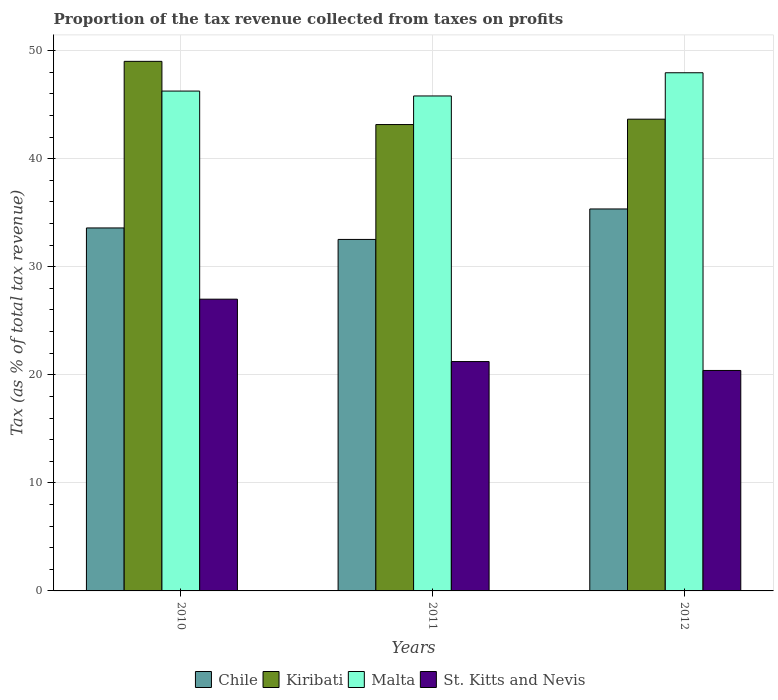How many different coloured bars are there?
Offer a very short reply. 4. What is the label of the 2nd group of bars from the left?
Your answer should be very brief. 2011. In how many cases, is the number of bars for a given year not equal to the number of legend labels?
Offer a very short reply. 0. What is the proportion of the tax revenue collected in Kiribati in 2011?
Your answer should be very brief. 43.16. Across all years, what is the maximum proportion of the tax revenue collected in St. Kitts and Nevis?
Your answer should be compact. 27. Across all years, what is the minimum proportion of the tax revenue collected in St. Kitts and Nevis?
Keep it short and to the point. 20.4. In which year was the proportion of the tax revenue collected in Chile maximum?
Offer a very short reply. 2012. What is the total proportion of the tax revenue collected in Chile in the graph?
Provide a succinct answer. 101.46. What is the difference between the proportion of the tax revenue collected in St. Kitts and Nevis in 2010 and that in 2011?
Ensure brevity in your answer.  5.77. What is the difference between the proportion of the tax revenue collected in Kiribati in 2011 and the proportion of the tax revenue collected in Chile in 2012?
Your response must be concise. 7.81. What is the average proportion of the tax revenue collected in St. Kitts and Nevis per year?
Offer a very short reply. 22.87. In the year 2010, what is the difference between the proportion of the tax revenue collected in Chile and proportion of the tax revenue collected in Malta?
Your response must be concise. -12.67. In how many years, is the proportion of the tax revenue collected in Chile greater than 28 %?
Provide a short and direct response. 3. What is the ratio of the proportion of the tax revenue collected in St. Kitts and Nevis in 2011 to that in 2012?
Provide a succinct answer. 1.04. Is the proportion of the tax revenue collected in Malta in 2010 less than that in 2011?
Ensure brevity in your answer.  No. What is the difference between the highest and the second highest proportion of the tax revenue collected in Chile?
Your answer should be very brief. 1.76. What is the difference between the highest and the lowest proportion of the tax revenue collected in Kiribati?
Your response must be concise. 5.85. In how many years, is the proportion of the tax revenue collected in Malta greater than the average proportion of the tax revenue collected in Malta taken over all years?
Your answer should be very brief. 1. Is the sum of the proportion of the tax revenue collected in Malta in 2010 and 2011 greater than the maximum proportion of the tax revenue collected in Kiribati across all years?
Offer a very short reply. Yes. What does the 4th bar from the left in 2011 represents?
Give a very brief answer. St. Kitts and Nevis. What does the 4th bar from the right in 2011 represents?
Your answer should be compact. Chile. How many years are there in the graph?
Give a very brief answer. 3. Does the graph contain any zero values?
Keep it short and to the point. No. What is the title of the graph?
Provide a short and direct response. Proportion of the tax revenue collected from taxes on profits. Does "Europe(developing only)" appear as one of the legend labels in the graph?
Your answer should be very brief. No. What is the label or title of the Y-axis?
Offer a terse response. Tax (as % of total tax revenue). What is the Tax (as % of total tax revenue) in Chile in 2010?
Provide a succinct answer. 33.59. What is the Tax (as % of total tax revenue) of Kiribati in 2010?
Offer a terse response. 49. What is the Tax (as % of total tax revenue) in Malta in 2010?
Provide a short and direct response. 46.25. What is the Tax (as % of total tax revenue) of St. Kitts and Nevis in 2010?
Give a very brief answer. 27. What is the Tax (as % of total tax revenue) in Chile in 2011?
Your response must be concise. 32.53. What is the Tax (as % of total tax revenue) in Kiribati in 2011?
Provide a short and direct response. 43.16. What is the Tax (as % of total tax revenue) in Malta in 2011?
Provide a succinct answer. 45.8. What is the Tax (as % of total tax revenue) in St. Kitts and Nevis in 2011?
Offer a very short reply. 21.23. What is the Tax (as % of total tax revenue) of Chile in 2012?
Offer a very short reply. 35.35. What is the Tax (as % of total tax revenue) in Kiribati in 2012?
Your answer should be compact. 43.65. What is the Tax (as % of total tax revenue) in Malta in 2012?
Keep it short and to the point. 47.95. What is the Tax (as % of total tax revenue) in St. Kitts and Nevis in 2012?
Your response must be concise. 20.4. Across all years, what is the maximum Tax (as % of total tax revenue) of Chile?
Your answer should be compact. 35.35. Across all years, what is the maximum Tax (as % of total tax revenue) of Kiribati?
Offer a very short reply. 49. Across all years, what is the maximum Tax (as % of total tax revenue) of Malta?
Provide a succinct answer. 47.95. Across all years, what is the maximum Tax (as % of total tax revenue) of St. Kitts and Nevis?
Ensure brevity in your answer.  27. Across all years, what is the minimum Tax (as % of total tax revenue) of Chile?
Offer a terse response. 32.53. Across all years, what is the minimum Tax (as % of total tax revenue) in Kiribati?
Give a very brief answer. 43.16. Across all years, what is the minimum Tax (as % of total tax revenue) of Malta?
Offer a very short reply. 45.8. Across all years, what is the minimum Tax (as % of total tax revenue) in St. Kitts and Nevis?
Provide a short and direct response. 20.4. What is the total Tax (as % of total tax revenue) of Chile in the graph?
Keep it short and to the point. 101.46. What is the total Tax (as % of total tax revenue) of Kiribati in the graph?
Offer a very short reply. 135.81. What is the total Tax (as % of total tax revenue) of Malta in the graph?
Your response must be concise. 140.01. What is the total Tax (as % of total tax revenue) in St. Kitts and Nevis in the graph?
Offer a very short reply. 68.62. What is the difference between the Tax (as % of total tax revenue) in Chile in 2010 and that in 2011?
Keep it short and to the point. 1.06. What is the difference between the Tax (as % of total tax revenue) of Kiribati in 2010 and that in 2011?
Your response must be concise. 5.85. What is the difference between the Tax (as % of total tax revenue) of Malta in 2010 and that in 2011?
Offer a very short reply. 0.45. What is the difference between the Tax (as % of total tax revenue) in St. Kitts and Nevis in 2010 and that in 2011?
Your response must be concise. 5.77. What is the difference between the Tax (as % of total tax revenue) in Chile in 2010 and that in 2012?
Your answer should be very brief. -1.76. What is the difference between the Tax (as % of total tax revenue) in Kiribati in 2010 and that in 2012?
Provide a short and direct response. 5.35. What is the difference between the Tax (as % of total tax revenue) in Malta in 2010 and that in 2012?
Make the answer very short. -1.69. What is the difference between the Tax (as % of total tax revenue) in St. Kitts and Nevis in 2010 and that in 2012?
Offer a terse response. 6.6. What is the difference between the Tax (as % of total tax revenue) of Chile in 2011 and that in 2012?
Provide a short and direct response. -2.82. What is the difference between the Tax (as % of total tax revenue) in Kiribati in 2011 and that in 2012?
Offer a terse response. -0.5. What is the difference between the Tax (as % of total tax revenue) in Malta in 2011 and that in 2012?
Keep it short and to the point. -2.15. What is the difference between the Tax (as % of total tax revenue) in St. Kitts and Nevis in 2011 and that in 2012?
Offer a terse response. 0.82. What is the difference between the Tax (as % of total tax revenue) in Chile in 2010 and the Tax (as % of total tax revenue) in Kiribati in 2011?
Keep it short and to the point. -9.57. What is the difference between the Tax (as % of total tax revenue) in Chile in 2010 and the Tax (as % of total tax revenue) in Malta in 2011?
Give a very brief answer. -12.21. What is the difference between the Tax (as % of total tax revenue) in Chile in 2010 and the Tax (as % of total tax revenue) in St. Kitts and Nevis in 2011?
Your answer should be compact. 12.36. What is the difference between the Tax (as % of total tax revenue) of Kiribati in 2010 and the Tax (as % of total tax revenue) of Malta in 2011?
Offer a very short reply. 3.2. What is the difference between the Tax (as % of total tax revenue) of Kiribati in 2010 and the Tax (as % of total tax revenue) of St. Kitts and Nevis in 2011?
Provide a short and direct response. 27.78. What is the difference between the Tax (as % of total tax revenue) in Malta in 2010 and the Tax (as % of total tax revenue) in St. Kitts and Nevis in 2011?
Provide a short and direct response. 25.03. What is the difference between the Tax (as % of total tax revenue) of Chile in 2010 and the Tax (as % of total tax revenue) of Kiribati in 2012?
Your response must be concise. -10.06. What is the difference between the Tax (as % of total tax revenue) in Chile in 2010 and the Tax (as % of total tax revenue) in Malta in 2012?
Ensure brevity in your answer.  -14.36. What is the difference between the Tax (as % of total tax revenue) of Chile in 2010 and the Tax (as % of total tax revenue) of St. Kitts and Nevis in 2012?
Keep it short and to the point. 13.19. What is the difference between the Tax (as % of total tax revenue) in Kiribati in 2010 and the Tax (as % of total tax revenue) in Malta in 2012?
Offer a very short reply. 1.06. What is the difference between the Tax (as % of total tax revenue) in Kiribati in 2010 and the Tax (as % of total tax revenue) in St. Kitts and Nevis in 2012?
Give a very brief answer. 28.6. What is the difference between the Tax (as % of total tax revenue) of Malta in 2010 and the Tax (as % of total tax revenue) of St. Kitts and Nevis in 2012?
Your answer should be compact. 25.85. What is the difference between the Tax (as % of total tax revenue) in Chile in 2011 and the Tax (as % of total tax revenue) in Kiribati in 2012?
Offer a very short reply. -11.13. What is the difference between the Tax (as % of total tax revenue) of Chile in 2011 and the Tax (as % of total tax revenue) of Malta in 2012?
Your answer should be compact. -15.42. What is the difference between the Tax (as % of total tax revenue) of Chile in 2011 and the Tax (as % of total tax revenue) of St. Kitts and Nevis in 2012?
Make the answer very short. 12.12. What is the difference between the Tax (as % of total tax revenue) of Kiribati in 2011 and the Tax (as % of total tax revenue) of Malta in 2012?
Your answer should be compact. -4.79. What is the difference between the Tax (as % of total tax revenue) of Kiribati in 2011 and the Tax (as % of total tax revenue) of St. Kitts and Nevis in 2012?
Give a very brief answer. 22.76. What is the difference between the Tax (as % of total tax revenue) in Malta in 2011 and the Tax (as % of total tax revenue) in St. Kitts and Nevis in 2012?
Provide a short and direct response. 25.4. What is the average Tax (as % of total tax revenue) of Chile per year?
Your response must be concise. 33.82. What is the average Tax (as % of total tax revenue) in Kiribati per year?
Offer a terse response. 45.27. What is the average Tax (as % of total tax revenue) in Malta per year?
Your answer should be compact. 46.67. What is the average Tax (as % of total tax revenue) in St. Kitts and Nevis per year?
Your response must be concise. 22.87. In the year 2010, what is the difference between the Tax (as % of total tax revenue) of Chile and Tax (as % of total tax revenue) of Kiribati?
Provide a succinct answer. -15.42. In the year 2010, what is the difference between the Tax (as % of total tax revenue) in Chile and Tax (as % of total tax revenue) in Malta?
Provide a short and direct response. -12.67. In the year 2010, what is the difference between the Tax (as % of total tax revenue) of Chile and Tax (as % of total tax revenue) of St. Kitts and Nevis?
Provide a short and direct response. 6.59. In the year 2010, what is the difference between the Tax (as % of total tax revenue) of Kiribati and Tax (as % of total tax revenue) of Malta?
Offer a terse response. 2.75. In the year 2010, what is the difference between the Tax (as % of total tax revenue) in Kiribati and Tax (as % of total tax revenue) in St. Kitts and Nevis?
Provide a succinct answer. 22.01. In the year 2010, what is the difference between the Tax (as % of total tax revenue) in Malta and Tax (as % of total tax revenue) in St. Kitts and Nevis?
Your response must be concise. 19.26. In the year 2011, what is the difference between the Tax (as % of total tax revenue) in Chile and Tax (as % of total tax revenue) in Kiribati?
Offer a very short reply. -10.63. In the year 2011, what is the difference between the Tax (as % of total tax revenue) of Chile and Tax (as % of total tax revenue) of Malta?
Offer a very short reply. -13.28. In the year 2011, what is the difference between the Tax (as % of total tax revenue) of Chile and Tax (as % of total tax revenue) of St. Kitts and Nevis?
Make the answer very short. 11.3. In the year 2011, what is the difference between the Tax (as % of total tax revenue) of Kiribati and Tax (as % of total tax revenue) of Malta?
Your response must be concise. -2.65. In the year 2011, what is the difference between the Tax (as % of total tax revenue) in Kiribati and Tax (as % of total tax revenue) in St. Kitts and Nevis?
Your answer should be very brief. 21.93. In the year 2011, what is the difference between the Tax (as % of total tax revenue) of Malta and Tax (as % of total tax revenue) of St. Kitts and Nevis?
Make the answer very short. 24.58. In the year 2012, what is the difference between the Tax (as % of total tax revenue) in Chile and Tax (as % of total tax revenue) in Kiribati?
Your answer should be compact. -8.31. In the year 2012, what is the difference between the Tax (as % of total tax revenue) of Chile and Tax (as % of total tax revenue) of Malta?
Offer a very short reply. -12.6. In the year 2012, what is the difference between the Tax (as % of total tax revenue) of Chile and Tax (as % of total tax revenue) of St. Kitts and Nevis?
Provide a succinct answer. 14.94. In the year 2012, what is the difference between the Tax (as % of total tax revenue) in Kiribati and Tax (as % of total tax revenue) in Malta?
Give a very brief answer. -4.3. In the year 2012, what is the difference between the Tax (as % of total tax revenue) of Kiribati and Tax (as % of total tax revenue) of St. Kitts and Nevis?
Ensure brevity in your answer.  23.25. In the year 2012, what is the difference between the Tax (as % of total tax revenue) of Malta and Tax (as % of total tax revenue) of St. Kitts and Nevis?
Give a very brief answer. 27.55. What is the ratio of the Tax (as % of total tax revenue) in Chile in 2010 to that in 2011?
Keep it short and to the point. 1.03. What is the ratio of the Tax (as % of total tax revenue) in Kiribati in 2010 to that in 2011?
Offer a very short reply. 1.14. What is the ratio of the Tax (as % of total tax revenue) in Malta in 2010 to that in 2011?
Provide a short and direct response. 1.01. What is the ratio of the Tax (as % of total tax revenue) in St. Kitts and Nevis in 2010 to that in 2011?
Make the answer very short. 1.27. What is the ratio of the Tax (as % of total tax revenue) in Chile in 2010 to that in 2012?
Your response must be concise. 0.95. What is the ratio of the Tax (as % of total tax revenue) in Kiribati in 2010 to that in 2012?
Your answer should be compact. 1.12. What is the ratio of the Tax (as % of total tax revenue) of Malta in 2010 to that in 2012?
Your answer should be compact. 0.96. What is the ratio of the Tax (as % of total tax revenue) of St. Kitts and Nevis in 2010 to that in 2012?
Provide a succinct answer. 1.32. What is the ratio of the Tax (as % of total tax revenue) of Chile in 2011 to that in 2012?
Your response must be concise. 0.92. What is the ratio of the Tax (as % of total tax revenue) of Malta in 2011 to that in 2012?
Keep it short and to the point. 0.96. What is the ratio of the Tax (as % of total tax revenue) in St. Kitts and Nevis in 2011 to that in 2012?
Offer a very short reply. 1.04. What is the difference between the highest and the second highest Tax (as % of total tax revenue) of Chile?
Your answer should be compact. 1.76. What is the difference between the highest and the second highest Tax (as % of total tax revenue) in Kiribati?
Keep it short and to the point. 5.35. What is the difference between the highest and the second highest Tax (as % of total tax revenue) in Malta?
Make the answer very short. 1.69. What is the difference between the highest and the second highest Tax (as % of total tax revenue) of St. Kitts and Nevis?
Offer a very short reply. 5.77. What is the difference between the highest and the lowest Tax (as % of total tax revenue) in Chile?
Keep it short and to the point. 2.82. What is the difference between the highest and the lowest Tax (as % of total tax revenue) in Kiribati?
Give a very brief answer. 5.85. What is the difference between the highest and the lowest Tax (as % of total tax revenue) of Malta?
Offer a terse response. 2.15. What is the difference between the highest and the lowest Tax (as % of total tax revenue) in St. Kitts and Nevis?
Keep it short and to the point. 6.6. 